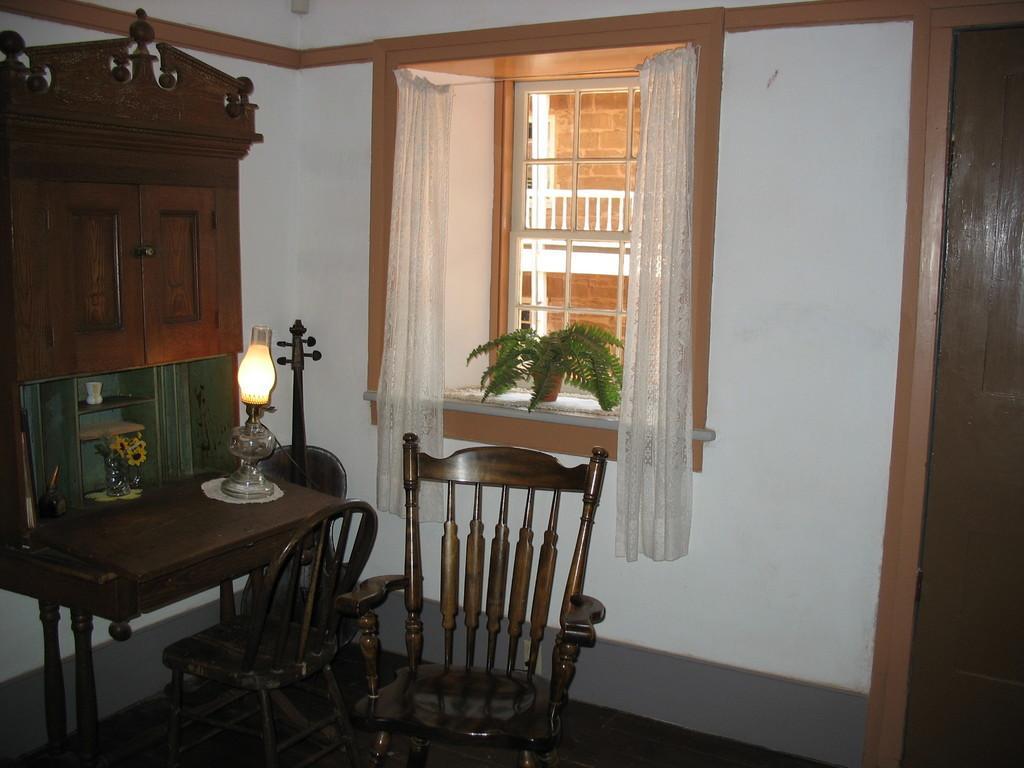Could you give a brief overview of what you see in this image? In this image there are chairs, lantern on the table, plant , cup, cupboard, wall, curtains, window, and in the background there is a building. 